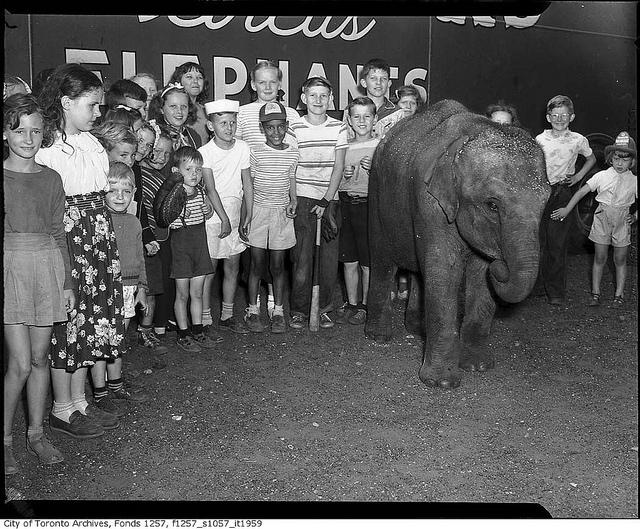What is the elephants trunk doing?

Choices:
A) curling
B) spraying
C) drawing
D) grabbing curling 